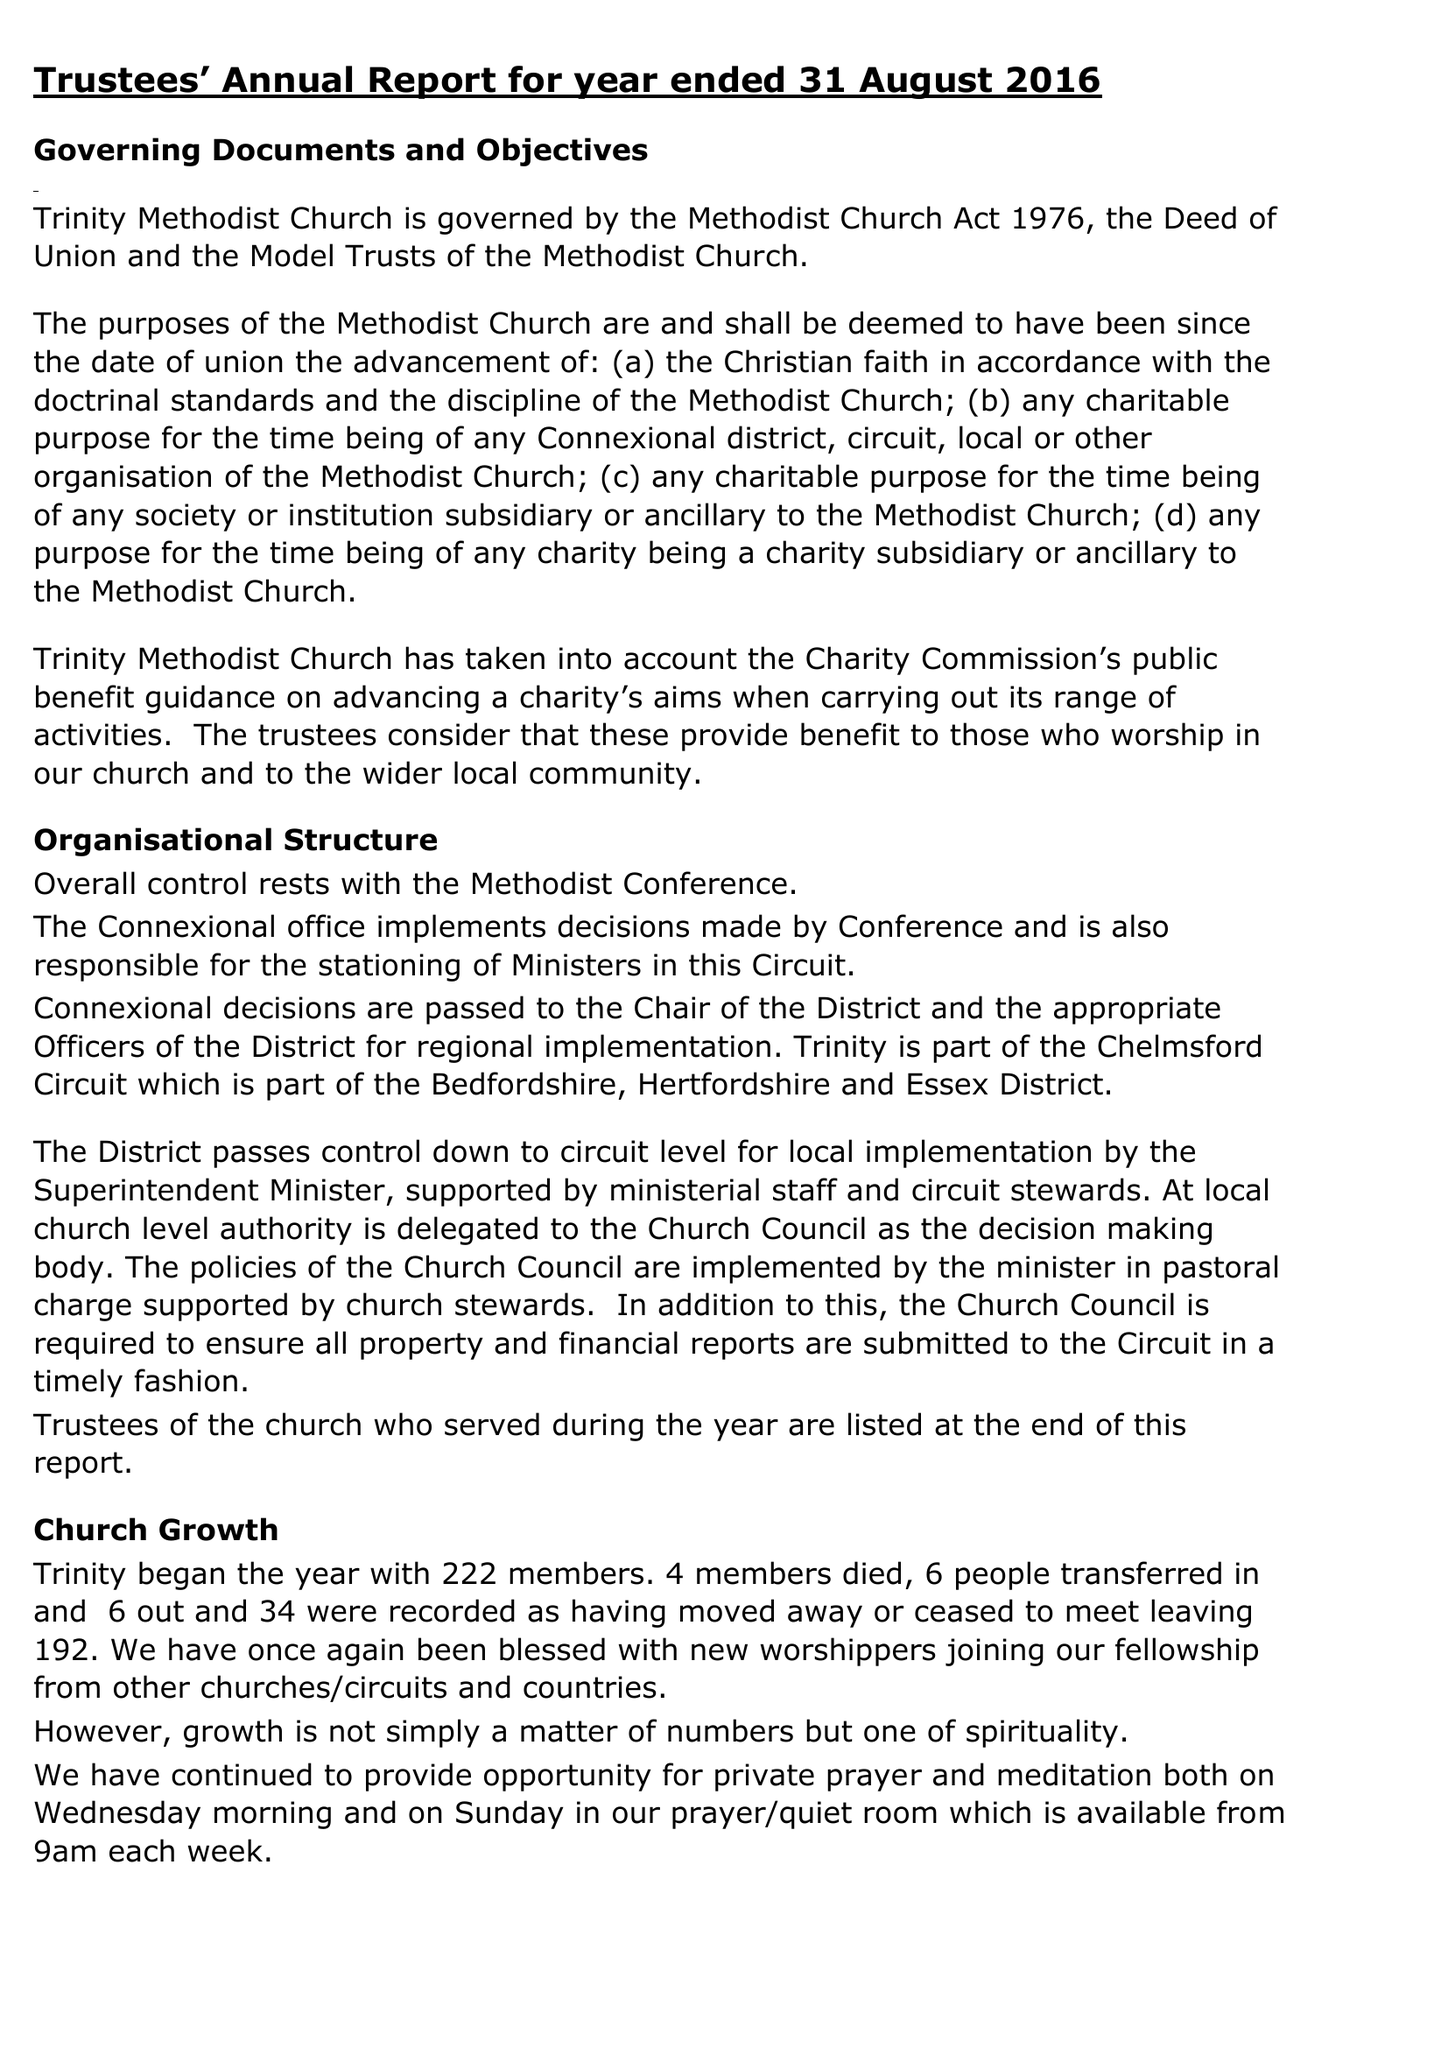What is the value for the charity_name?
Answer the question using a single word or phrase. Trinity Methodist Church Chelmsford 